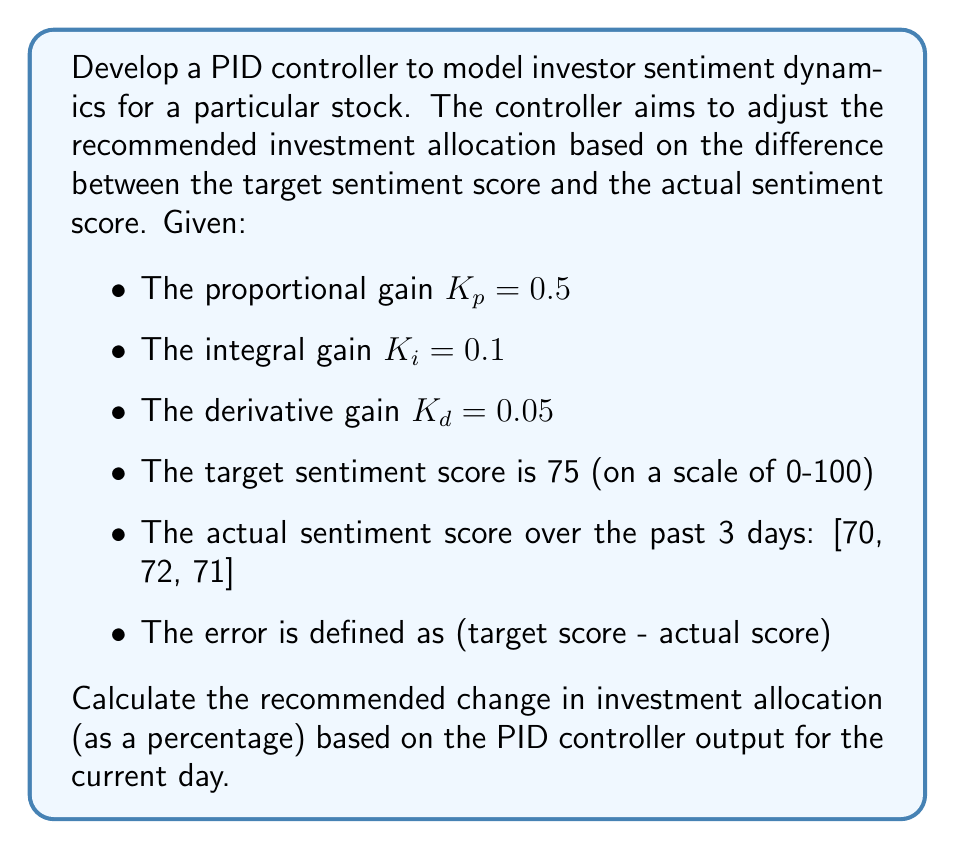Can you answer this question? To solve this problem, we'll use the PID controller equation:

$$u(t) = K_p e(t) + K_i \int_0^t e(\tau) d\tau + K_d \frac{de(t)}{dt}$$

Where:
$u(t)$ is the controller output
$e(t)$ is the error
$t$ is time

Let's break this down step-by-step:

1. Calculate the current error:
   $e(t) = 75 - 71 = 4$

2. Calculate the integral of the error (sum of errors over time):
   $\int_0^t e(\tau) d\tau = (75-70) + (75-72) + (75-71) = 5 + 3 + 4 = 12$

3. Calculate the derivative of the error (change in error):
   $\frac{de(t)}{dt} = (71 - 72) = -1$

4. Apply the PID equation:
   $u(t) = 0.5 \cdot 4 + 0.1 \cdot 12 + 0.05 \cdot (-1)$

5. Solve the equation:
   $u(t) = 2 + 1.2 - 0.05 = 3.15$

The output of 3.15 represents the recommended change in investment allocation as a percentage. A positive value indicates an increase in allocation, while a negative value would indicate a decrease.
Answer: The recommended change in investment allocation based on the PID controller output is an increase of 3.15%. 